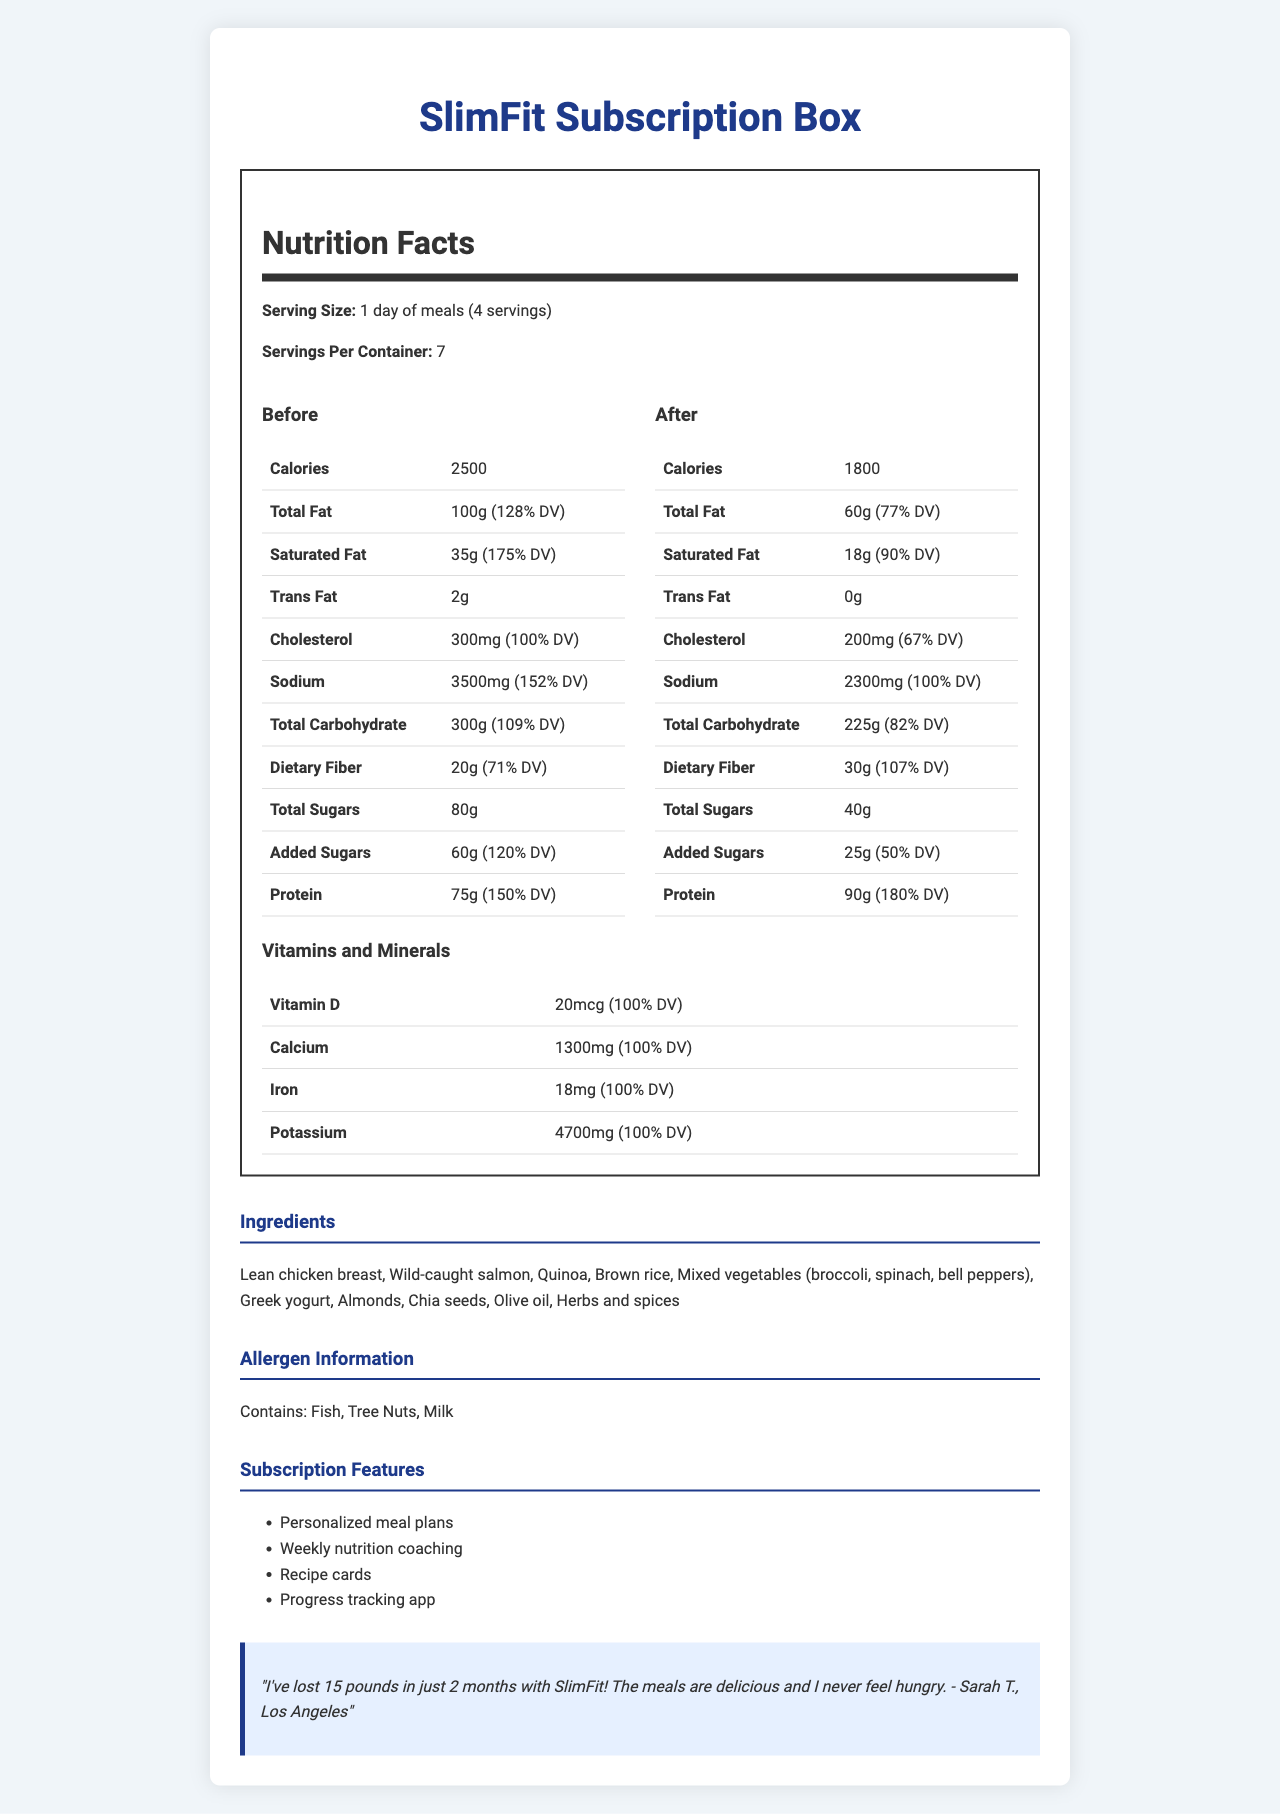what is the serving size of the SlimFit Subscription Box? The serving size is clearly indicated under the Nutrition Facts section as "1 day of meals (4 servings)".
Answer: 1 day of meals (4 servings) how many servings are there per container? This information is listed below the serving size in the Nutrition Facts section as "Servings Per Container: 7".
Answer: 7 how many calories are in the 'before' profile? The number of calories in the 'before' profile is listed in the table under the 'Before' column as 2500 calories.
Answer: 2500 how many grams of protein are in the 'after' profile? The 'after' profile indicates 90 grams of protein in the corresponding row of the table under the 'After' column.
Answer: 90g what is the percentage daily value of sodium in the ' after' profile? The table under the 'After' profile shows that the daily value percentage for sodium is 100%.
Answer: 100% what is the main difference in trans fat content between the 'before' and 'after' profiles? A. It increased B. It decreased C. There is no trans fat in the 'after' profile The 'before' profile shows 2g of trans fat while the 'after' profile shows 0g, indicating that trans fat has been eliminated in the 'after' profile.
Answer: C. There is no trans fat in the 'after' profile which vitamin has a 100% daily value in both profiles? A. Vitamin D B. Calcium C. Iron D. Potassium The document shows that the daily value for Vitamin D is 100% in both the 'before' and 'after' profiles, while other vitamins' percentages are not directly compared.
Answer: A. Vitamin D is there more dietary fiber in the 'after' profile compared to the 'before' profile? The 'after' profile lists 30g of dietary fiber compared to 20g in the 'before' profile, indicating an increase.
Answer: Yes describe the main idea of the document. The entire document presents a detailed analysis of the nutritional improvements provided by the SlimFit Subscription Box, emphasizing healthier macronutrient distributions and better ingredient choices, along with additional subscription benefits.
Answer: The document provides a comparative Nutrition Facts Label for the SlimFit Subscription Box, showcasing the differences in macronutrient profiles before and after using the subscription box. The 'after' profile highlights reduced calories, fats, added sugars, and sodium while increasing fiber and protein. It also details the ingredients, allergen information, subscription features, and includes a customer testimonial. what are the allergens listed in the allergen information section? The allergen information section lists "Contains: Fish, Tree Nuts, Milk".
Answer: Fish, Tree Nuts, Milk how much iron is in the SlimFit Subscription Box? In the Vitamins and Minerals section, the document indicates that the box contains 18 mg of iron.
Answer: 18 mg how many grams of total sugars are in the 'before' profile? The 'before' profile indicates a total of 80 grams of total sugars.
Answer: 80g which feature is not mentioned under the subscription features section? A. Social Media Community B. Weekly nutrition coaching C. Progress tracking app The Subscription Features section lists personalized meal plans, weekly nutrition coaching, recipe cards, and a progress tracking app, but not a social media community.
Answer: A. Social Media Community how much vitamin D is in the box? The amount of vitamin D in the box is listed as 20 mcg under the Vitamins and Minerals section.
Answer: 20 mcg what health benefit did Sarah T. mention in her testimonial? Sarah T. mentioned that she lost 15 pounds in just 2 months using the SlimFit Subscription Box.
Answer: Weight loss of 15 pounds what is the main protein source in the ingredient list? The main protein sources listed in the ingredient section are lean chicken breast and wild-caught salmon.
Answer: Lean chicken breast, Wild-caught salmon how much cholesterol is in the 'after' profile? The document lists 200 mg of cholesterol in the 'after' profile.
Answer: 200 mg how many calories are in a single serving of the SlimFit Subscription Box? The document provides the serving size as "1 day of meals (4 servings)" and total calories for the profiles, but it does not provide enough information to determine the calories in a single serving.
Answer: Cannot be determined 